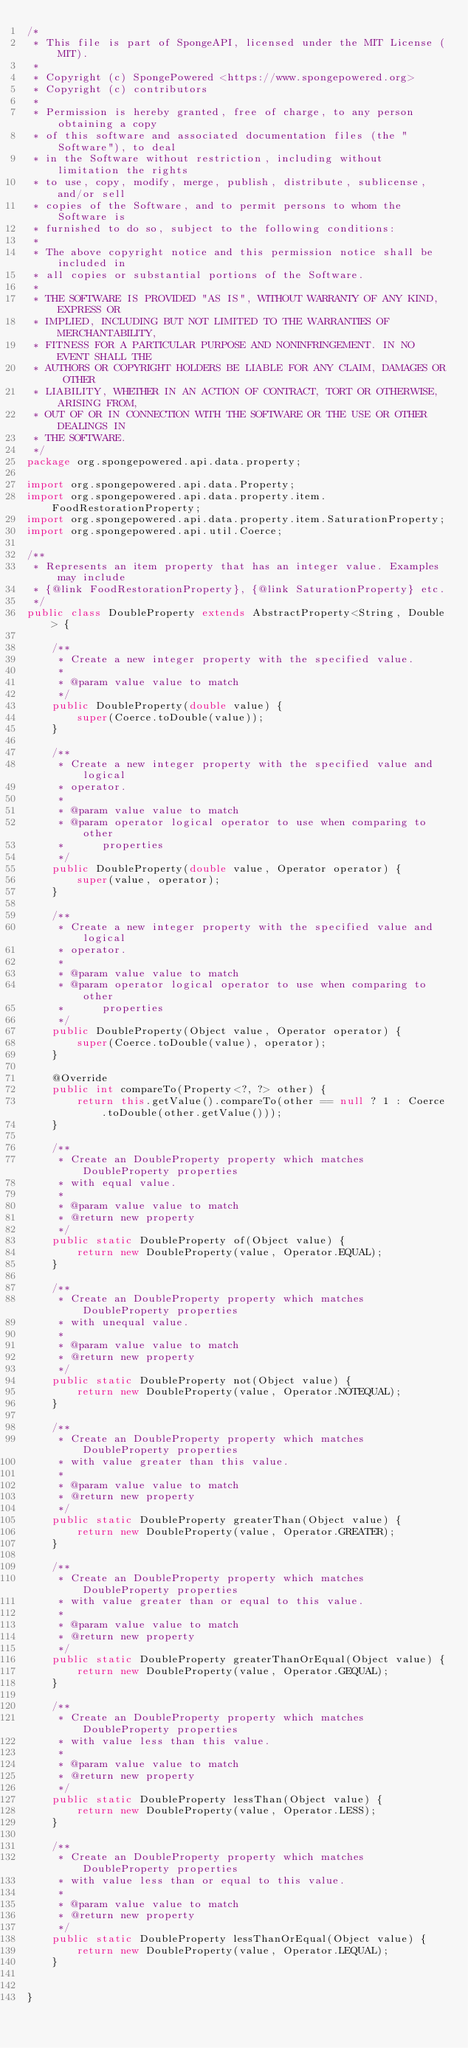Convert code to text. <code><loc_0><loc_0><loc_500><loc_500><_Java_>/*
 * This file is part of SpongeAPI, licensed under the MIT License (MIT).
 *
 * Copyright (c) SpongePowered <https://www.spongepowered.org>
 * Copyright (c) contributors
 *
 * Permission is hereby granted, free of charge, to any person obtaining a copy
 * of this software and associated documentation files (the "Software"), to deal
 * in the Software without restriction, including without limitation the rights
 * to use, copy, modify, merge, publish, distribute, sublicense, and/or sell
 * copies of the Software, and to permit persons to whom the Software is
 * furnished to do so, subject to the following conditions:
 *
 * The above copyright notice and this permission notice shall be included in
 * all copies or substantial portions of the Software.
 *
 * THE SOFTWARE IS PROVIDED "AS IS", WITHOUT WARRANTY OF ANY KIND, EXPRESS OR
 * IMPLIED, INCLUDING BUT NOT LIMITED TO THE WARRANTIES OF MERCHANTABILITY,
 * FITNESS FOR A PARTICULAR PURPOSE AND NONINFRINGEMENT. IN NO EVENT SHALL THE
 * AUTHORS OR COPYRIGHT HOLDERS BE LIABLE FOR ANY CLAIM, DAMAGES OR OTHER
 * LIABILITY, WHETHER IN AN ACTION OF CONTRACT, TORT OR OTHERWISE, ARISING FROM,
 * OUT OF OR IN CONNECTION WITH THE SOFTWARE OR THE USE OR OTHER DEALINGS IN
 * THE SOFTWARE.
 */
package org.spongepowered.api.data.property;

import org.spongepowered.api.data.Property;
import org.spongepowered.api.data.property.item.FoodRestorationProperty;
import org.spongepowered.api.data.property.item.SaturationProperty;
import org.spongepowered.api.util.Coerce;

/**
 * Represents an item property that has an integer value. Examples may include
 * {@link FoodRestorationProperty}, {@link SaturationProperty} etc.
 */
public class DoubleProperty extends AbstractProperty<String, Double> {

    /**
     * Create a new integer property with the specified value.
     *
     * @param value value to match
     */
    public DoubleProperty(double value) {
        super(Coerce.toDouble(value));
    }

    /**
     * Create a new integer property with the specified value and logical
     * operator.
     *
     * @param value value to match
     * @param operator logical operator to use when comparing to other
     *      properties
     */
    public DoubleProperty(double value, Operator operator) {
        super(value, operator);
    }

    /**
     * Create a new integer property with the specified value and logical
     * operator.
     *
     * @param value value to match
     * @param operator logical operator to use when comparing to other
     *      properties
     */
    public DoubleProperty(Object value, Operator operator) {
        super(Coerce.toDouble(value), operator);
    }

    @Override
    public int compareTo(Property<?, ?> other) {
        return this.getValue().compareTo(other == null ? 1 : Coerce.toDouble(other.getValue()));
    }

    /**
     * Create an DoubleProperty property which matches DoubleProperty properties
     * with equal value.
     *
     * @param value value to match
     * @return new property
     */
    public static DoubleProperty of(Object value) {
        return new DoubleProperty(value, Operator.EQUAL);
    }

    /**
     * Create an DoubleProperty property which matches DoubleProperty properties
     * with unequal value.
     *
     * @param value value to match
     * @return new property
     */
    public static DoubleProperty not(Object value) {
        return new DoubleProperty(value, Operator.NOTEQUAL);
    }

    /**
     * Create an DoubleProperty property which matches DoubleProperty properties
     * with value greater than this value.
     *
     * @param value value to match
     * @return new property
     */
    public static DoubleProperty greaterThan(Object value) {
        return new DoubleProperty(value, Operator.GREATER);
    }

    /**
     * Create an DoubleProperty property which matches DoubleProperty properties
     * with value greater than or equal to this value.
     *
     * @param value value to match
     * @return new property
     */
    public static DoubleProperty greaterThanOrEqual(Object value) {
        return new DoubleProperty(value, Operator.GEQUAL);
    }

    /**
     * Create an DoubleProperty property which matches DoubleProperty properties
     * with value less than this value.
     *
     * @param value value to match
     * @return new property
     */
    public static DoubleProperty lessThan(Object value) {
        return new DoubleProperty(value, Operator.LESS);
    }

    /**
     * Create an DoubleProperty property which matches DoubleProperty properties
     * with value less than or equal to this value.
     *
     * @param value value to match
     * @return new property
     */
    public static DoubleProperty lessThanOrEqual(Object value) {
        return new DoubleProperty(value, Operator.LEQUAL);
    }


}
</code> 